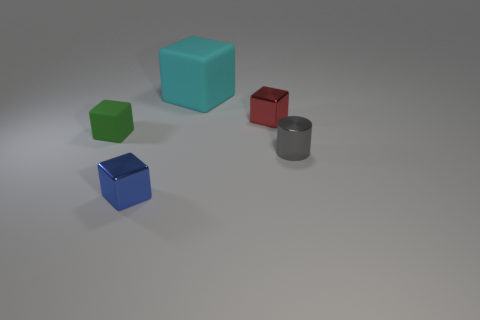There is a cube that is both left of the small red metallic cube and to the right of the blue thing; what is its size?
Ensure brevity in your answer.  Large. What size is the red metallic object that is the same shape as the large cyan matte object?
Offer a very short reply. Small. There is a metal block in front of the gray metallic thing; is its size the same as the gray thing in front of the tiny red shiny block?
Your answer should be compact. Yes. How many objects are either cubes on the left side of the large cyan object or things behind the gray metallic cylinder?
Give a very brief answer. 4. Are the big block and the small object left of the blue cube made of the same material?
Keep it short and to the point. Yes. What shape is the metal thing that is both right of the cyan rubber thing and in front of the green block?
Your response must be concise. Cylinder. What number of other things are there of the same color as the tiny matte cube?
Keep it short and to the point. 0. What is the shape of the small gray object?
Give a very brief answer. Cylinder. There is a metal cube behind the small block in front of the tiny green rubber block; what color is it?
Your answer should be compact. Red. The small cube that is right of the tiny rubber cube and behind the blue metallic thing is made of what material?
Keep it short and to the point. Metal. 